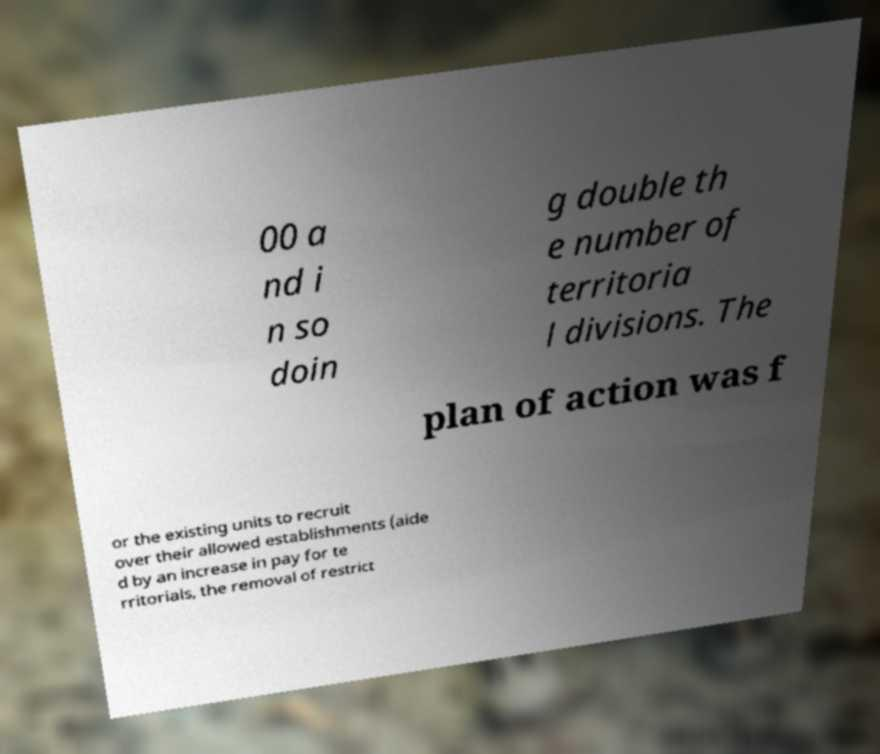Could you assist in decoding the text presented in this image and type it out clearly? 00 a nd i n so doin g double th e number of territoria l divisions. The plan of action was f or the existing units to recruit over their allowed establishments (aide d by an increase in pay for te rritorials, the removal of restrict 